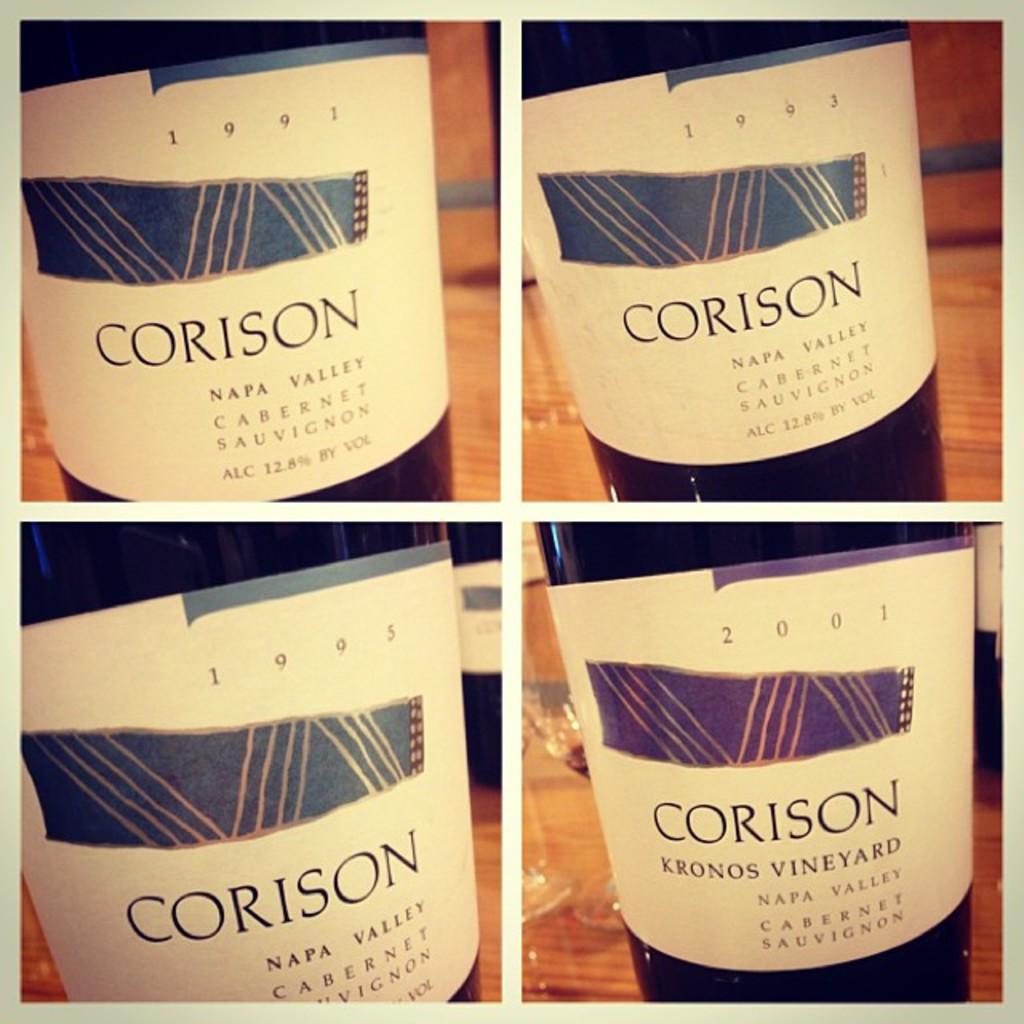What kind of wine is this?
Provide a short and direct response. Cabernet sauvignon. What year is the wine to the left?
Offer a terse response. 1991. 